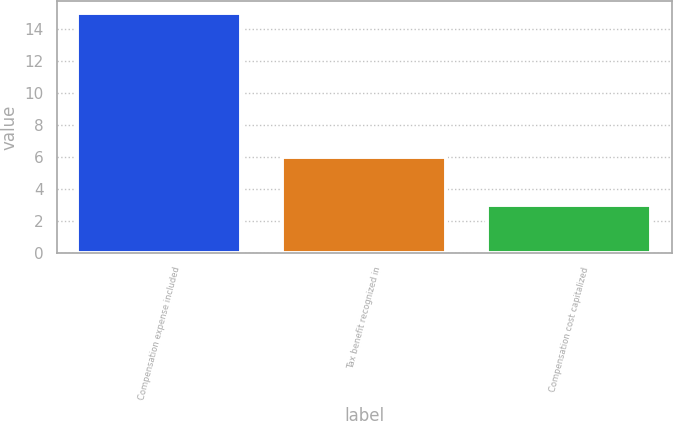Convert chart. <chart><loc_0><loc_0><loc_500><loc_500><bar_chart><fcel>Compensation expense included<fcel>Tax benefit recognized in<fcel>Compensation cost capitalized<nl><fcel>15<fcel>6<fcel>3<nl></chart> 